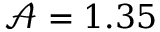Convert formula to latex. <formula><loc_0><loc_0><loc_500><loc_500>\mathcal { A } = 1 . 3 5</formula> 